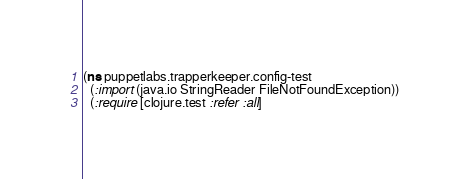<code> <loc_0><loc_0><loc_500><loc_500><_Clojure_>(ns puppetlabs.trapperkeeper.config-test
  (:import (java.io StringReader FileNotFoundException))
  (:require [clojure.test :refer :all]</code> 